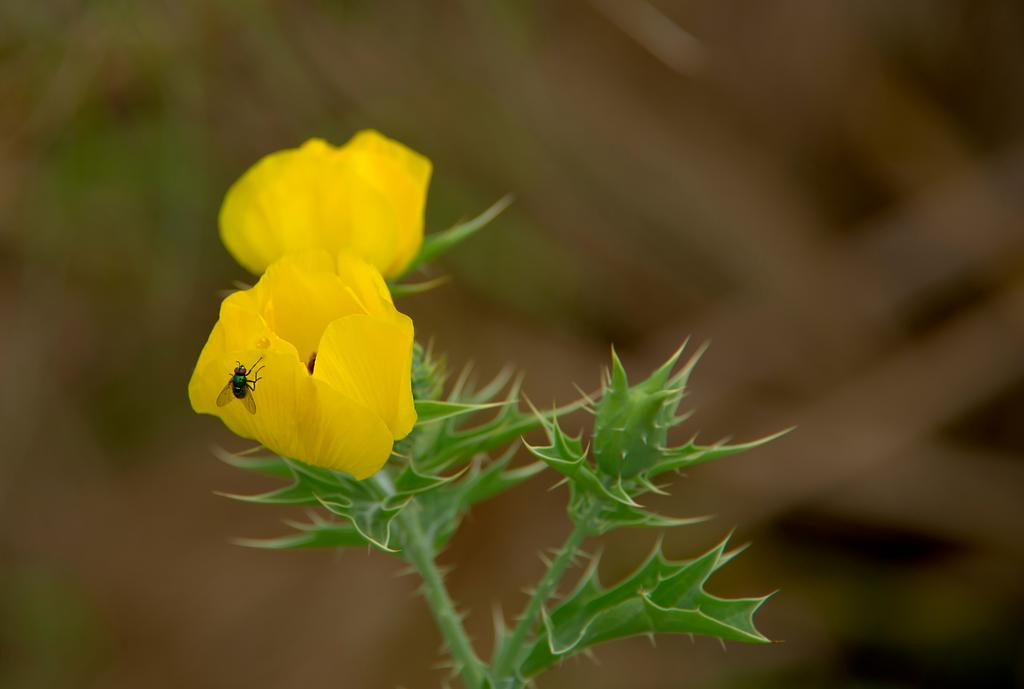What is present in the image that is small and has wings? There is a fly in the image that is small and has wings. Where is the fly located in the image? The fly is sitting on a flower in the image. What is the flower attached to in the image? The flower is on a plant in the image. What type of scent is emitted by the hole in the image? There is no hole present in the image, so there is no scent associated with it. 